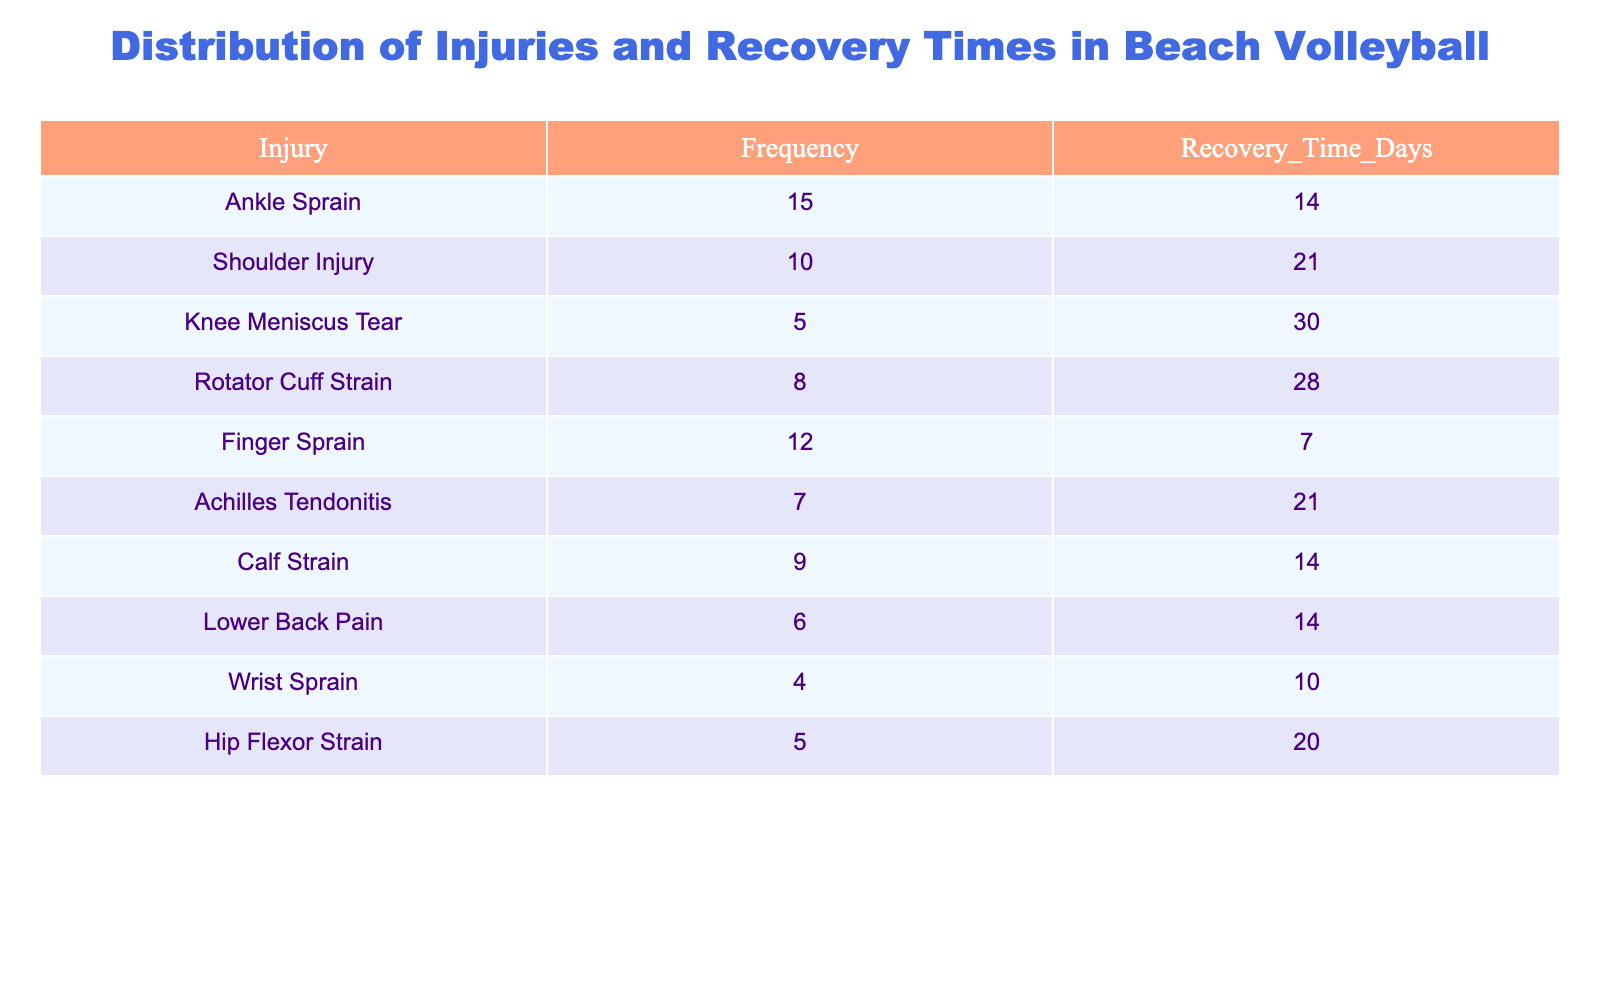What is the most common injury in beach volleyball? The table lists the injuries along with their frequencies. The frequency of injuries shows that the most common injury is "Ankle Sprain" with a frequency of 15.
Answer: Ankle Sprain How many injuries have a frequency of 10 or more? By reviewing the frequency column, we can see the injuries with frequencies 15 (Ankle Sprain), 10 (Shoulder Injury), 12 (Finger Sprain), and 9 (Calf Strain). There are 4 injuries that have a frequency of 10 or more.
Answer: 4 What is the recovery time for a Knee Meniscus Tear? The table indicates the recovery time for each injury. For a Knee Meniscus Tear, the recovery time is listed as 30 days.
Answer: 30 days What is the average recovery time for all listed injuries? To find the average recovery time, we sum all the recovery times: (14 + 21 + 30 + 28 + 7 + 21 + 14 + 14 + 10 + 20) =  7 + 10 = 7 + 14 = 216. There are 10 injuries, so the average recovery time is 216 / 10 = 21.6 days.
Answer: 21.6 days Is there an injury with a recovery time of less than 10 days? We check the recovery times in the table. The recovery times are 14, 21, 30, 28, 7, 21, 14, 14, 10, and 20. Since the minimum recovery time listed is 7 days, this indicates yes, there is an injury with a recovery time of less than 10 days (Finger Sprain).
Answer: Yes What injury has the longest recovery time? By examining the recovery times in the table, the longest recovery time is 30 days, which is associated with the Knee Meniscus Tear.
Answer: Knee Meniscus Tear How many injuries have a recovery time of 21 days or more? We examine the recovery times in the table and find that the injuries with recovery times of 21 days or more are: Shoulder Injury (21), Knee Meniscus Tear (30), Rotator Cuff Strain (28), and Achilles Tendonitis (21). Thus, there are 4 such injuries.
Answer: 4 What is the total frequency of injuries that are associated with shoulder problems? The injuries that are related to the shoulder are the "Shoulder Injury" and "Rotator Cuff Strain." Their frequencies are 10 and 8 respectively. The total frequency of these injuries is 10 + 8 = 18.
Answer: 18 